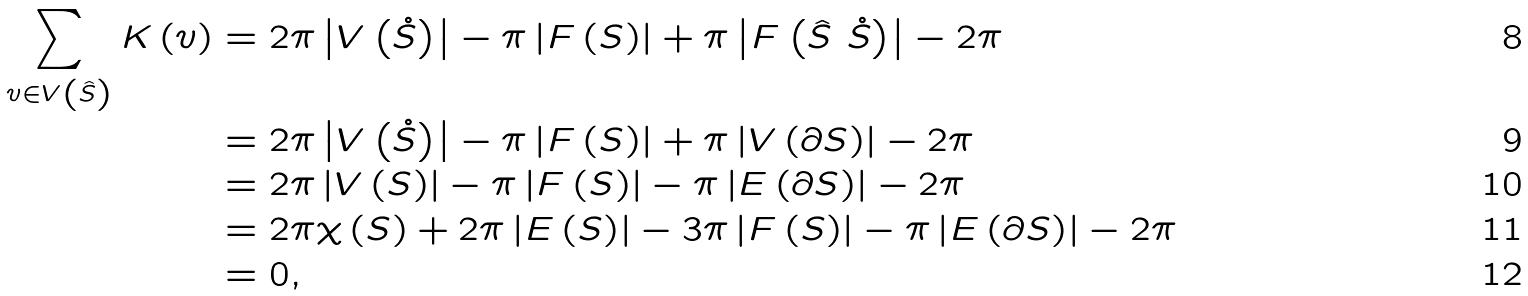Convert formula to latex. <formula><loc_0><loc_0><loc_500><loc_500>\sum _ { v \in V \left ( \hat { S } \right ) } K \left ( v \right ) & = 2 \pi \left | V \left ( \mathring { S } \right ) \right | - \pi \left | F \left ( S \right ) \right | + \pi \left | F \left ( \hat { S } \ \mathring { S } \right ) \right | - 2 \pi \\ & = 2 \pi \left | V \left ( \mathring { S } \right ) \right | - \pi \left | F \left ( S \right ) \right | + \pi \left | V \left ( \partial S \right ) \right | - 2 \pi \\ & = 2 \pi \left | V \left ( S \right ) \right | - \pi \left | F \left ( S \right ) \right | - \pi \left | E \left ( \partial S \right ) \right | - 2 \pi \\ & = 2 \pi \chi \left ( S \right ) + 2 \pi \left | E \left ( S \right ) \right | - 3 \pi \left | F \left ( S \right ) \right | - \pi \left | E \left ( \partial S \right ) \right | - 2 \pi \\ & = 0 ,</formula> 